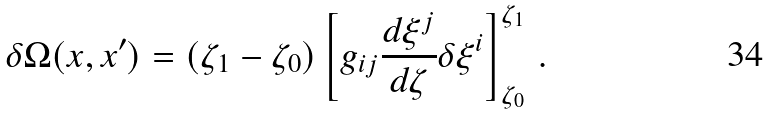Convert formula to latex. <formula><loc_0><loc_0><loc_500><loc_500>\delta \Omega ( x , x ^ { \prime } ) = ( \zeta _ { 1 } - \zeta _ { 0 } ) \left [ g _ { i j } \frac { d \xi ^ { j } } { d \zeta } \delta \xi ^ { i } \right ] _ { \zeta _ { 0 } } ^ { \zeta _ { 1 } } \, .</formula> 